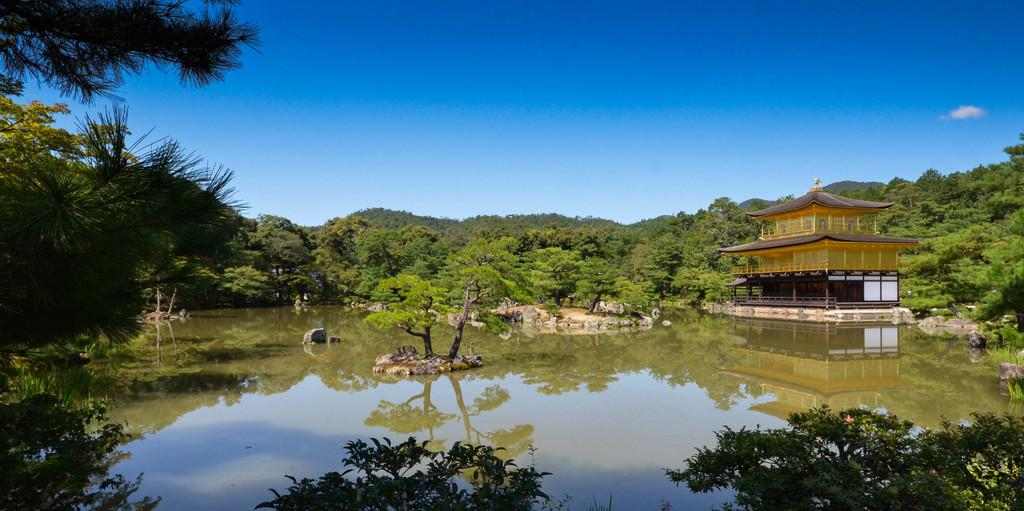What type of natural feature is present in the image? There is a water body in the image. What can be seen near the water body? There are trees and stones near the water body. What type of structure is visible in the image? There is a building in the image. What is visible in the background of the image? There are trees and the sky visible in the background of the image. What type of plants is your mom growing in the image? There is no reference to a mom or plants in the image; it features a water body, trees, stones, a building, and the sky. 